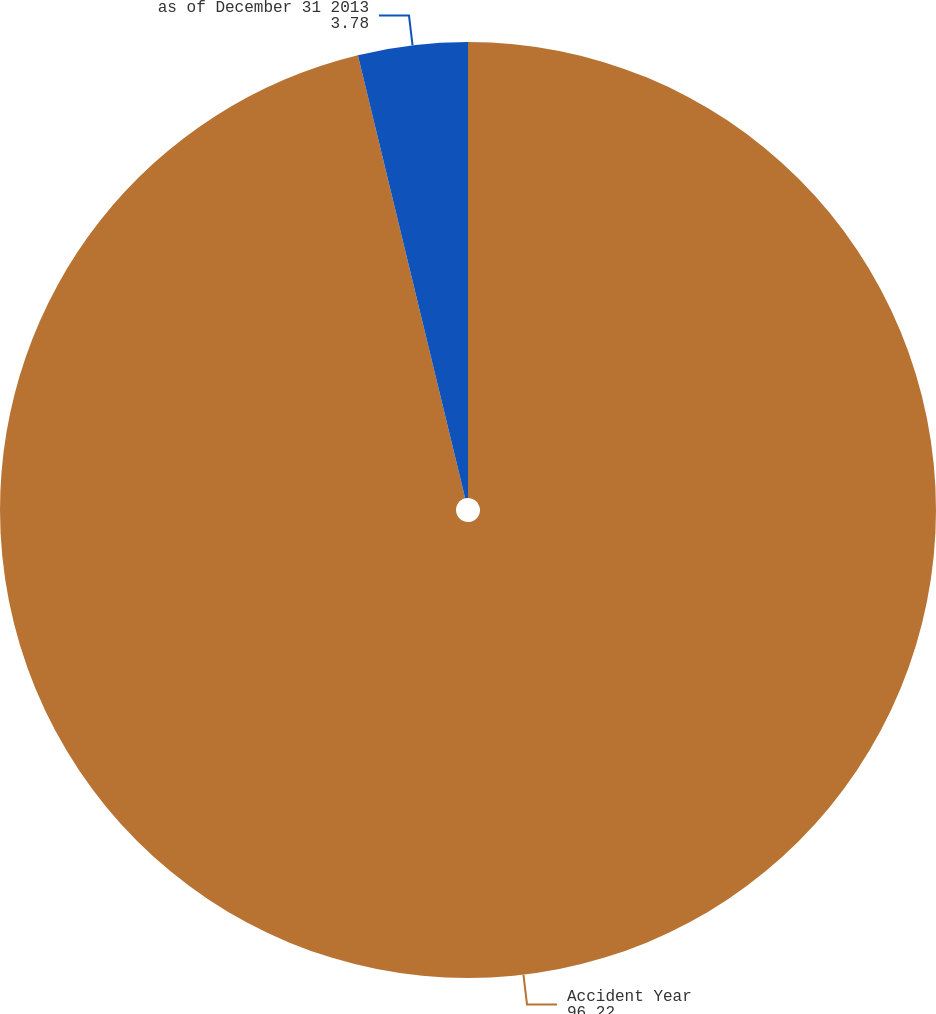<chart> <loc_0><loc_0><loc_500><loc_500><pie_chart><fcel>Accident Year<fcel>as of December 31 2013<nl><fcel>96.22%<fcel>3.78%<nl></chart> 